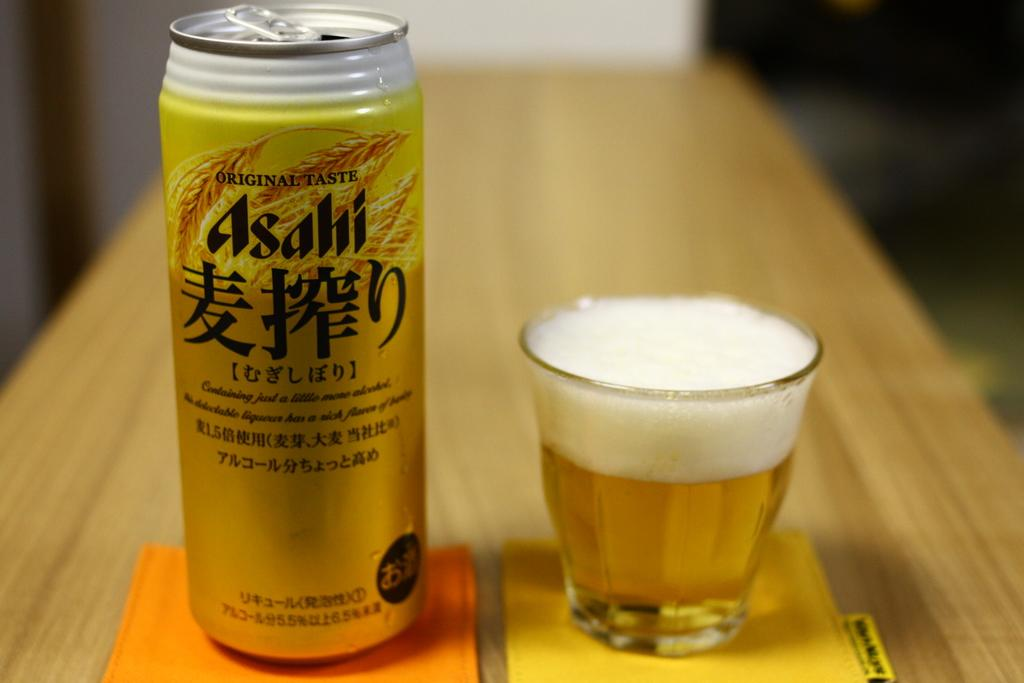Provide a one-sentence caption for the provided image. An original taste Asahi beer can sitting next to a glass filled with the beer. 